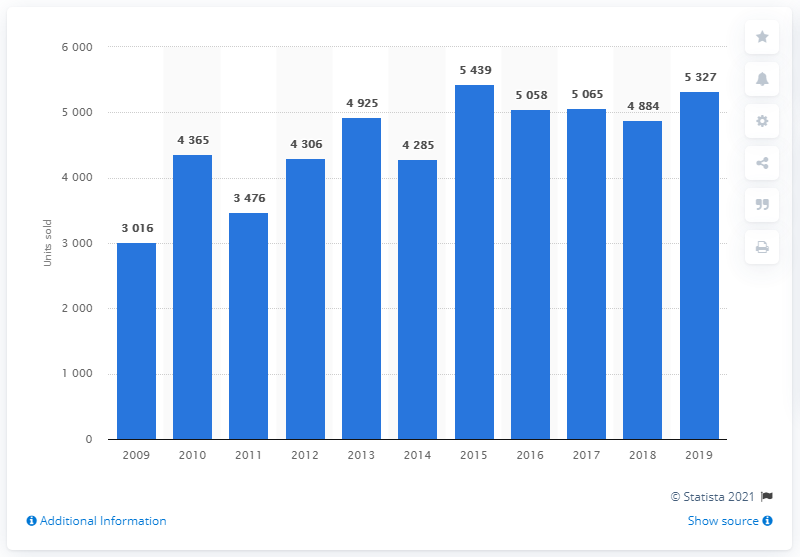Draw attention to some important aspects in this diagram. During the period of 2009 to 2019, the highest number of Subaru cars sold in Sweden was 5,439. In 2019, a total of 5,327 Subaru cars were sold in Sweden. 